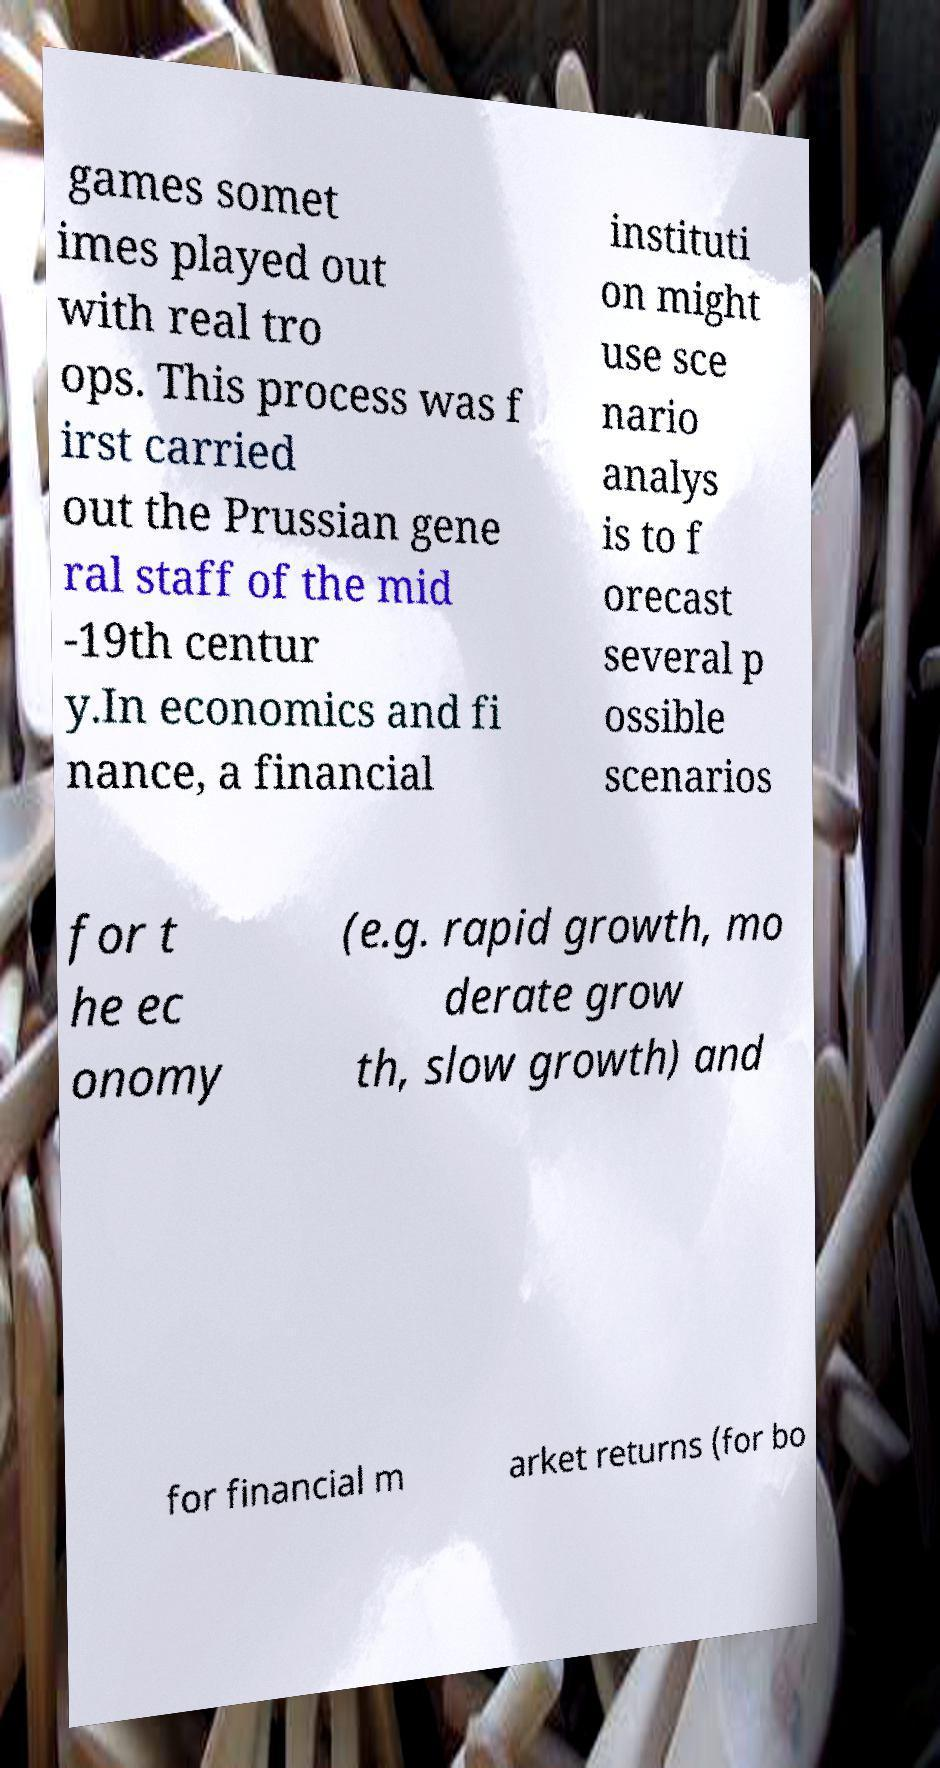There's text embedded in this image that I need extracted. Can you transcribe it verbatim? games somet imes played out with real tro ops. This process was f irst carried out the Prussian gene ral staff of the mid -19th centur y.In economics and fi nance, a financial instituti on might use sce nario analys is to f orecast several p ossible scenarios for t he ec onomy (e.g. rapid growth, mo derate grow th, slow growth) and for financial m arket returns (for bo 